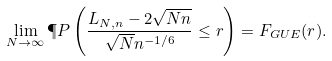Convert formula to latex. <formula><loc_0><loc_0><loc_500><loc_500>\lim _ { N \rightarrow \infty } \P P \left ( \frac { L _ { N , n } - 2 \sqrt { N n } } { \sqrt { N } n ^ { - 1 / 6 } } \leq r \right ) = F _ { G U E } ( r ) .</formula> 